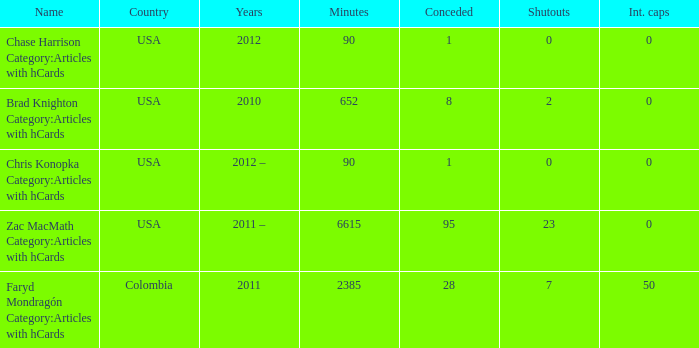When chase harrison category: writings with hcards is the designation, what is the year? 2012.0. 